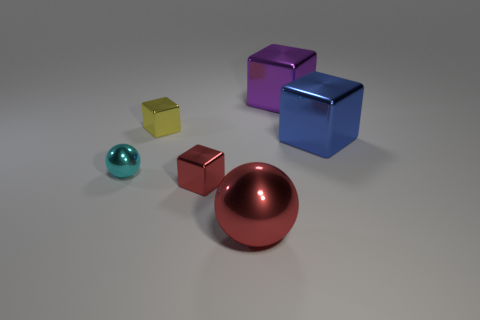Subtract all red cubes. How many cubes are left? 3 Subtract all yellow cubes. How many cubes are left? 3 Add 2 big red rubber things. How many objects exist? 8 Subtract all purple blocks. Subtract all red cylinders. How many blocks are left? 3 Subtract all balls. How many objects are left? 4 Subtract all small yellow metallic objects. Subtract all rubber balls. How many objects are left? 5 Add 4 red blocks. How many red blocks are left? 5 Add 3 red metal things. How many red metal things exist? 5 Subtract 0 purple balls. How many objects are left? 6 